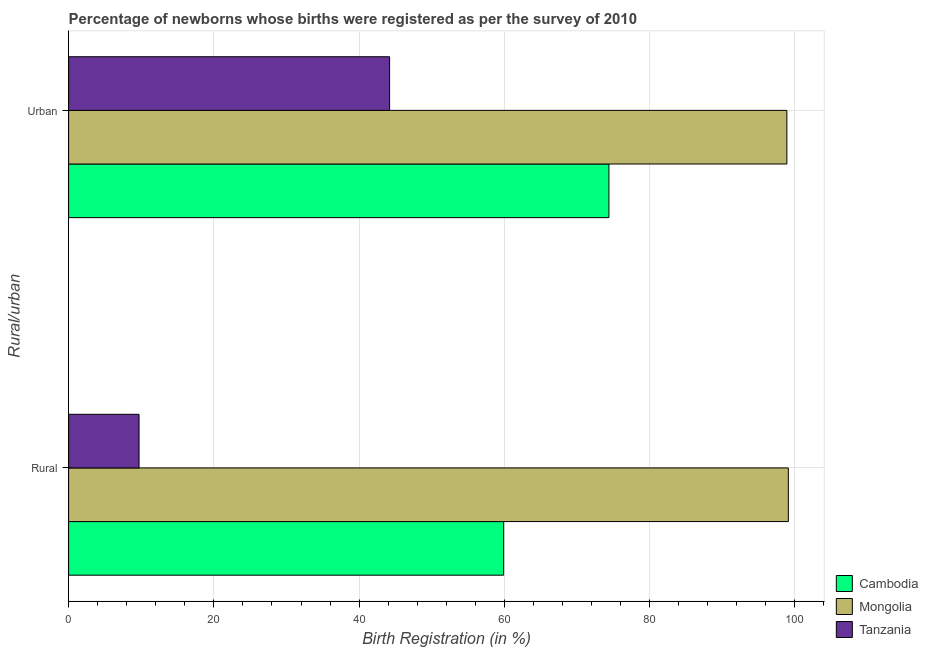How many different coloured bars are there?
Offer a very short reply. 3. How many groups of bars are there?
Offer a very short reply. 2. How many bars are there on the 2nd tick from the bottom?
Your answer should be compact. 3. What is the label of the 1st group of bars from the top?
Provide a succinct answer. Urban. What is the rural birth registration in Mongolia?
Your answer should be very brief. 99.1. Across all countries, what is the maximum urban birth registration?
Provide a short and direct response. 98.9. Across all countries, what is the minimum urban birth registration?
Your answer should be compact. 44.2. In which country was the rural birth registration maximum?
Keep it short and to the point. Mongolia. In which country was the urban birth registration minimum?
Your answer should be very brief. Tanzania. What is the total rural birth registration in the graph?
Provide a succinct answer. 168.7. What is the difference between the urban birth registration in Tanzania and that in Cambodia?
Your response must be concise. -30.2. What is the difference between the urban birth registration in Tanzania and the rural birth registration in Mongolia?
Ensure brevity in your answer.  -54.9. What is the average rural birth registration per country?
Ensure brevity in your answer.  56.23. What is the difference between the urban birth registration and rural birth registration in Tanzania?
Provide a short and direct response. 34.5. In how many countries, is the urban birth registration greater than 64 %?
Your answer should be compact. 2. What is the ratio of the urban birth registration in Cambodia to that in Mongolia?
Your answer should be compact. 0.75. In how many countries, is the urban birth registration greater than the average urban birth registration taken over all countries?
Offer a terse response. 2. What does the 1st bar from the top in Rural represents?
Your answer should be very brief. Tanzania. What does the 2nd bar from the bottom in Urban represents?
Ensure brevity in your answer.  Mongolia. How many bars are there?
Offer a terse response. 6. Does the graph contain any zero values?
Your response must be concise. No. Where does the legend appear in the graph?
Keep it short and to the point. Bottom right. How many legend labels are there?
Make the answer very short. 3. How are the legend labels stacked?
Provide a short and direct response. Vertical. What is the title of the graph?
Keep it short and to the point. Percentage of newborns whose births were registered as per the survey of 2010. Does "Mexico" appear as one of the legend labels in the graph?
Ensure brevity in your answer.  No. What is the label or title of the X-axis?
Make the answer very short. Birth Registration (in %). What is the label or title of the Y-axis?
Make the answer very short. Rural/urban. What is the Birth Registration (in %) of Cambodia in Rural?
Make the answer very short. 59.9. What is the Birth Registration (in %) in Mongolia in Rural?
Ensure brevity in your answer.  99.1. What is the Birth Registration (in %) in Tanzania in Rural?
Make the answer very short. 9.7. What is the Birth Registration (in %) of Cambodia in Urban?
Provide a succinct answer. 74.4. What is the Birth Registration (in %) in Mongolia in Urban?
Ensure brevity in your answer.  98.9. What is the Birth Registration (in %) in Tanzania in Urban?
Your answer should be compact. 44.2. Across all Rural/urban, what is the maximum Birth Registration (in %) of Cambodia?
Ensure brevity in your answer.  74.4. Across all Rural/urban, what is the maximum Birth Registration (in %) of Mongolia?
Give a very brief answer. 99.1. Across all Rural/urban, what is the maximum Birth Registration (in %) in Tanzania?
Give a very brief answer. 44.2. Across all Rural/urban, what is the minimum Birth Registration (in %) in Cambodia?
Give a very brief answer. 59.9. Across all Rural/urban, what is the minimum Birth Registration (in %) of Mongolia?
Give a very brief answer. 98.9. What is the total Birth Registration (in %) in Cambodia in the graph?
Your answer should be compact. 134.3. What is the total Birth Registration (in %) of Mongolia in the graph?
Make the answer very short. 198. What is the total Birth Registration (in %) of Tanzania in the graph?
Ensure brevity in your answer.  53.9. What is the difference between the Birth Registration (in %) in Cambodia in Rural and that in Urban?
Keep it short and to the point. -14.5. What is the difference between the Birth Registration (in %) of Tanzania in Rural and that in Urban?
Make the answer very short. -34.5. What is the difference between the Birth Registration (in %) of Cambodia in Rural and the Birth Registration (in %) of Mongolia in Urban?
Give a very brief answer. -39. What is the difference between the Birth Registration (in %) of Mongolia in Rural and the Birth Registration (in %) of Tanzania in Urban?
Give a very brief answer. 54.9. What is the average Birth Registration (in %) in Cambodia per Rural/urban?
Your response must be concise. 67.15. What is the average Birth Registration (in %) in Tanzania per Rural/urban?
Keep it short and to the point. 26.95. What is the difference between the Birth Registration (in %) of Cambodia and Birth Registration (in %) of Mongolia in Rural?
Make the answer very short. -39.2. What is the difference between the Birth Registration (in %) in Cambodia and Birth Registration (in %) in Tanzania in Rural?
Offer a very short reply. 50.2. What is the difference between the Birth Registration (in %) of Mongolia and Birth Registration (in %) of Tanzania in Rural?
Your answer should be very brief. 89.4. What is the difference between the Birth Registration (in %) of Cambodia and Birth Registration (in %) of Mongolia in Urban?
Keep it short and to the point. -24.5. What is the difference between the Birth Registration (in %) of Cambodia and Birth Registration (in %) of Tanzania in Urban?
Ensure brevity in your answer.  30.2. What is the difference between the Birth Registration (in %) of Mongolia and Birth Registration (in %) of Tanzania in Urban?
Provide a short and direct response. 54.7. What is the ratio of the Birth Registration (in %) of Cambodia in Rural to that in Urban?
Offer a very short reply. 0.81. What is the ratio of the Birth Registration (in %) of Mongolia in Rural to that in Urban?
Offer a very short reply. 1. What is the ratio of the Birth Registration (in %) of Tanzania in Rural to that in Urban?
Your response must be concise. 0.22. What is the difference between the highest and the second highest Birth Registration (in %) of Cambodia?
Make the answer very short. 14.5. What is the difference between the highest and the second highest Birth Registration (in %) in Mongolia?
Your answer should be compact. 0.2. What is the difference between the highest and the second highest Birth Registration (in %) in Tanzania?
Offer a terse response. 34.5. What is the difference between the highest and the lowest Birth Registration (in %) of Cambodia?
Ensure brevity in your answer.  14.5. What is the difference between the highest and the lowest Birth Registration (in %) of Tanzania?
Offer a terse response. 34.5. 